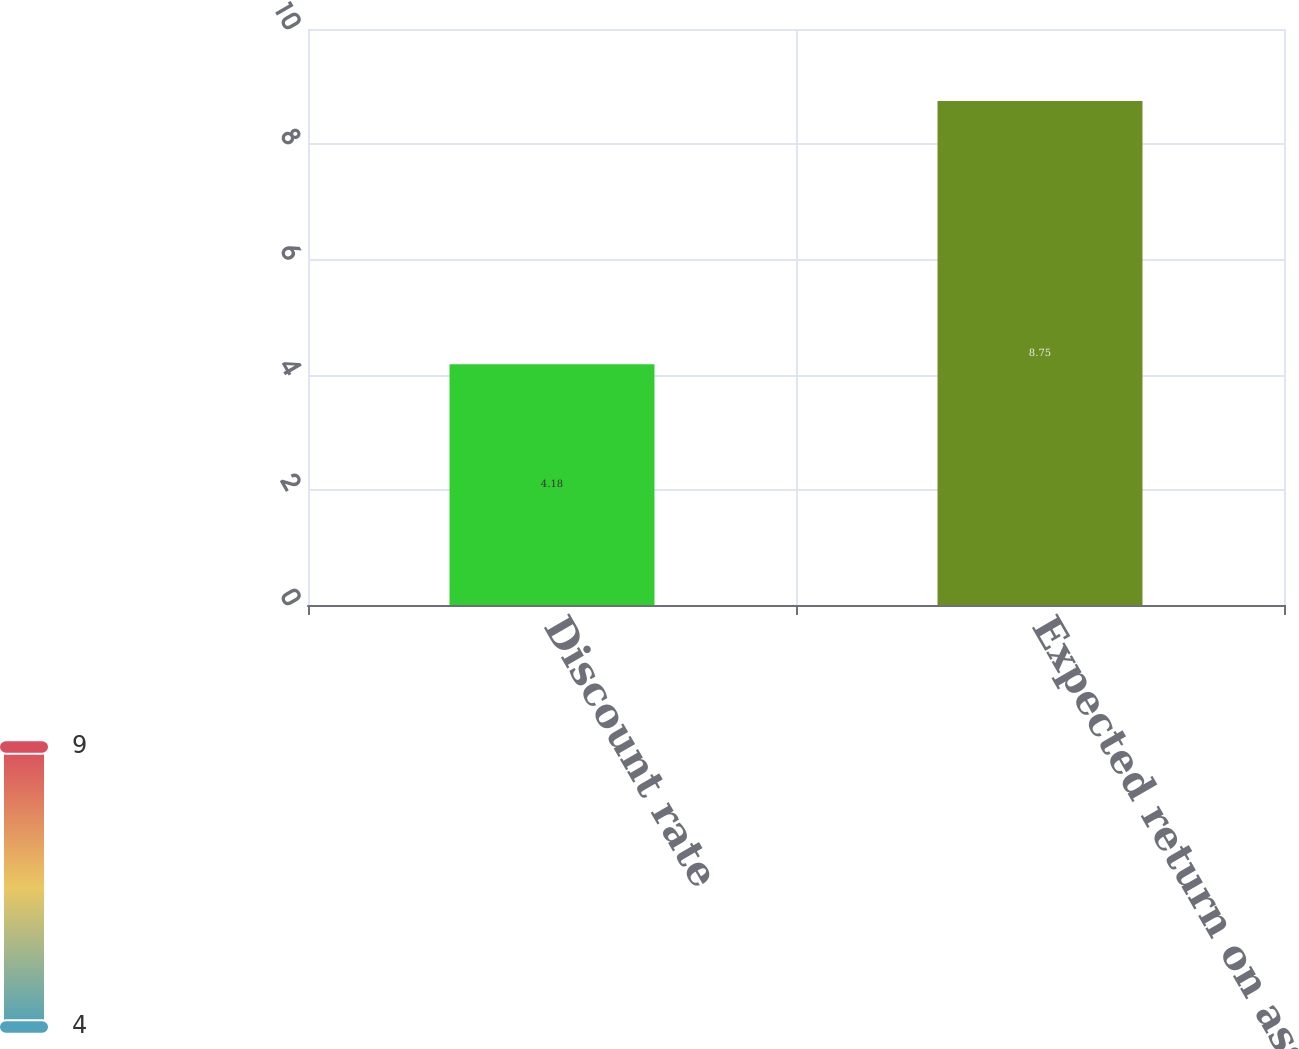Convert chart. <chart><loc_0><loc_0><loc_500><loc_500><bar_chart><fcel>Discount rate<fcel>Expected return on assets<nl><fcel>4.18<fcel>8.75<nl></chart> 